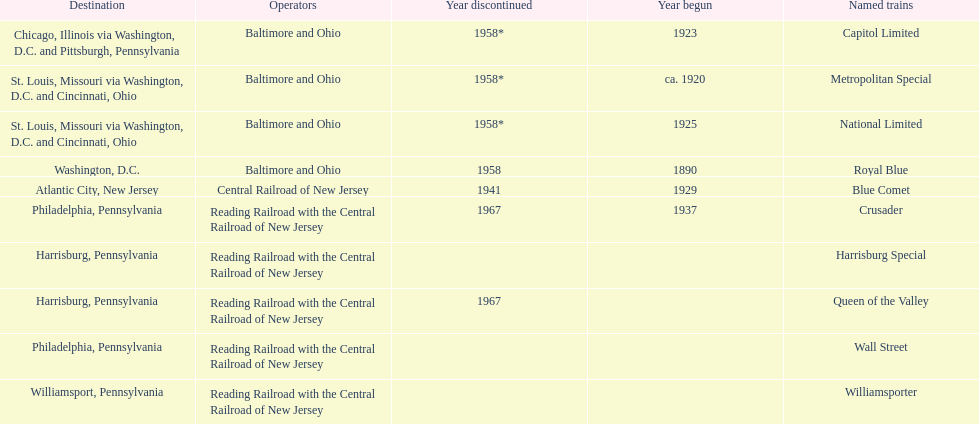Which train ran for the longest time? Royal Blue. 